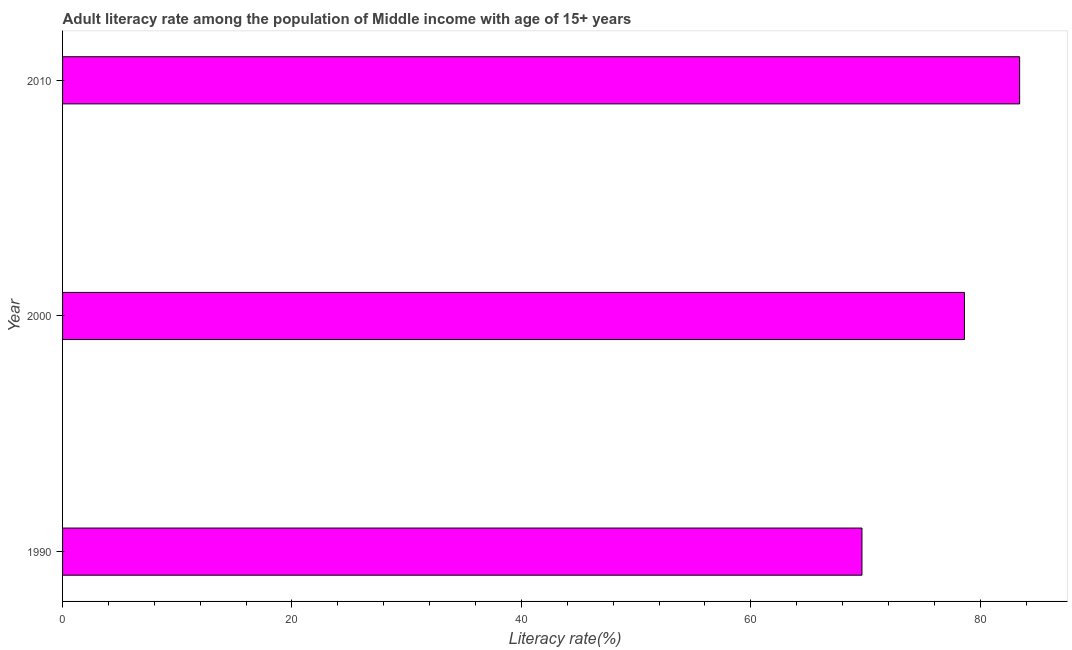Does the graph contain grids?
Your response must be concise. No. What is the title of the graph?
Provide a succinct answer. Adult literacy rate among the population of Middle income with age of 15+ years. What is the label or title of the X-axis?
Provide a short and direct response. Literacy rate(%). What is the adult literacy rate in 1990?
Your answer should be compact. 69.69. Across all years, what is the maximum adult literacy rate?
Offer a very short reply. 83.44. Across all years, what is the minimum adult literacy rate?
Give a very brief answer. 69.69. In which year was the adult literacy rate maximum?
Ensure brevity in your answer.  2010. What is the sum of the adult literacy rate?
Your response must be concise. 231.76. What is the difference between the adult literacy rate in 1990 and 2010?
Offer a terse response. -13.75. What is the average adult literacy rate per year?
Offer a very short reply. 77.25. What is the median adult literacy rate?
Provide a succinct answer. 78.63. In how many years, is the adult literacy rate greater than 60 %?
Give a very brief answer. 3. Do a majority of the years between 1990 and 2000 (inclusive) have adult literacy rate greater than 28 %?
Provide a succinct answer. Yes. What is the ratio of the adult literacy rate in 1990 to that in 2000?
Your answer should be very brief. 0.89. Is the adult literacy rate in 1990 less than that in 2010?
Keep it short and to the point. Yes. Is the difference between the adult literacy rate in 1990 and 2000 greater than the difference between any two years?
Provide a succinct answer. No. What is the difference between the highest and the second highest adult literacy rate?
Your answer should be compact. 4.81. Is the sum of the adult literacy rate in 2000 and 2010 greater than the maximum adult literacy rate across all years?
Your answer should be compact. Yes. What is the difference between the highest and the lowest adult literacy rate?
Your answer should be compact. 13.75. In how many years, is the adult literacy rate greater than the average adult literacy rate taken over all years?
Provide a short and direct response. 2. Are all the bars in the graph horizontal?
Offer a terse response. Yes. What is the Literacy rate(%) in 1990?
Your response must be concise. 69.69. What is the Literacy rate(%) in 2000?
Your answer should be compact. 78.63. What is the Literacy rate(%) of 2010?
Your answer should be very brief. 83.44. What is the difference between the Literacy rate(%) in 1990 and 2000?
Keep it short and to the point. -8.94. What is the difference between the Literacy rate(%) in 1990 and 2010?
Provide a succinct answer. -13.75. What is the difference between the Literacy rate(%) in 2000 and 2010?
Your answer should be compact. -4.81. What is the ratio of the Literacy rate(%) in 1990 to that in 2000?
Make the answer very short. 0.89. What is the ratio of the Literacy rate(%) in 1990 to that in 2010?
Make the answer very short. 0.83. What is the ratio of the Literacy rate(%) in 2000 to that in 2010?
Keep it short and to the point. 0.94. 